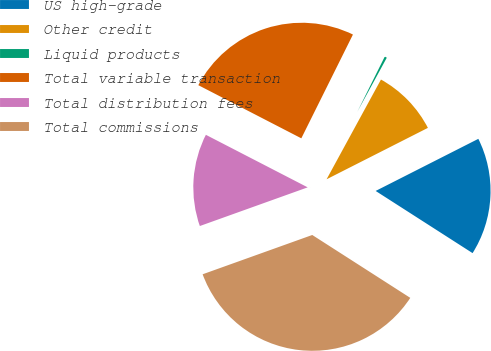<chart> <loc_0><loc_0><loc_500><loc_500><pie_chart><fcel>US high-grade<fcel>Other credit<fcel>Liquid products<fcel>Total variable transaction<fcel>Total distribution fees<fcel>Total commissions<nl><fcel>16.55%<fcel>9.58%<fcel>0.6%<fcel>24.76%<fcel>13.06%<fcel>35.44%<nl></chart> 